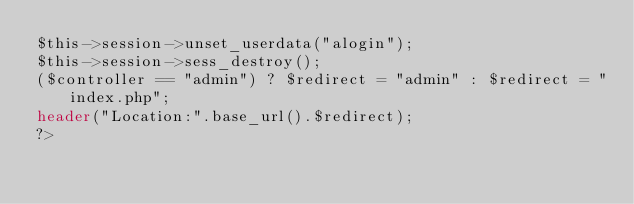Convert code to text. <code><loc_0><loc_0><loc_500><loc_500><_PHP_>$this->session->unset_userdata("alogin");
$this->session->sess_destroy();
($controller == "admin") ? $redirect = "admin" : $redirect = "index.php";
header("Location:".base_url().$redirect);
?>
</code> 